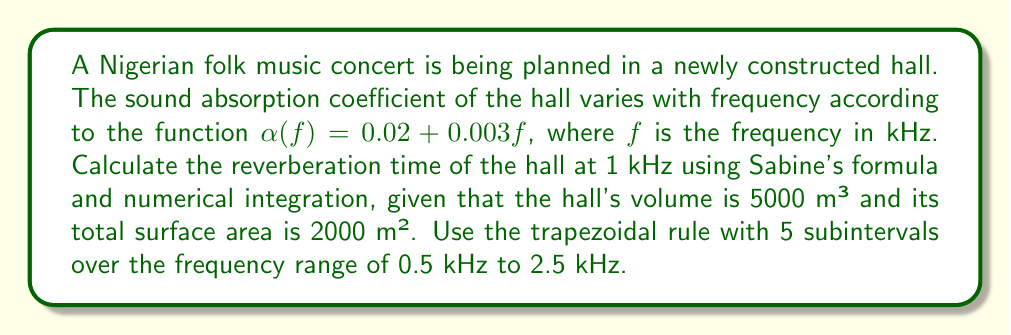Can you answer this question? 1) Sabine's formula for reverberation time is:

   $$T = \frac{0.161V}{A}$$

   where $V$ is the room volume and $A$ is the total absorption area.

2) The total absorption area $A$ is given by:

   $$A = S \cdot \bar{\alpha}$$

   where $S$ is the total surface area and $\bar{\alpha}$ is the average absorption coefficient.

3) We need to calculate $\bar{\alpha}$ using numerical integration (trapezoidal rule) over the given frequency range:

   $$\bar{\alpha} = \frac{1}{2 - 0.5} \int_{0.5}^{2.5} \alpha(f) df$$

4) Set up the trapezoidal rule with 5 subintervals:

   $$\bar{\alpha} \approx \frac{2.5 - 0.5}{2(5)} [\alpha(0.5) + 2\alpha(1.0) + 2\alpha(1.5) + 2\alpha(2.0) + \alpha(2.5)]$$

5) Calculate $\alpha(f)$ for each frequency:
   
   $\alpha(0.5) = 0.02 + 0.003(0.5) = 0.0215$
   $\alpha(1.0) = 0.02 + 0.003(1.0) = 0.0230$
   $\alpha(1.5) = 0.02 + 0.003(1.5) = 0.0245$
   $\alpha(2.0) = 0.02 + 0.003(2.0) = 0.0260$
   $\alpha(2.5) = 0.02 + 0.003(2.5) = 0.0275$

6) Apply the trapezoidal rule:

   $$\bar{\alpha} \approx 0.5 [0.0215 + 2(0.0230) + 2(0.0245) + 2(0.0260) + 0.0275] = 0.024$$

7) Calculate the total absorption area:

   $$A = S \cdot \bar{\alpha} = 2000 \cdot 0.024 = 48 \text{ m}^2$$

8) Finally, apply Sabine's formula:

   $$T = \frac{0.161 \cdot 5000}{48} \approx 16.77 \text{ seconds}$$
Answer: 16.77 seconds 